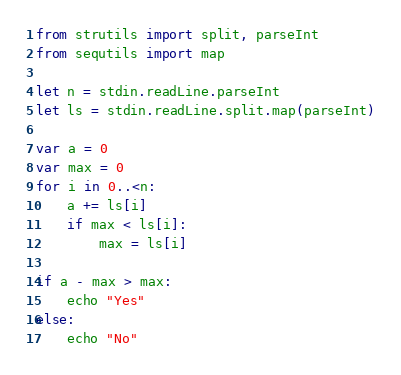Convert code to text. <code><loc_0><loc_0><loc_500><loc_500><_Nim_>from strutils import split, parseInt
from sequtils import map

let n = stdin.readLine.parseInt
let ls = stdin.readLine.split.map(parseInt)

var a = 0
var max = 0
for i in 0..<n:
    a += ls[i]
    if max < ls[i]:
        max = ls[i]

if a - max > max:
    echo "Yes"
else:
    echo "No"</code> 